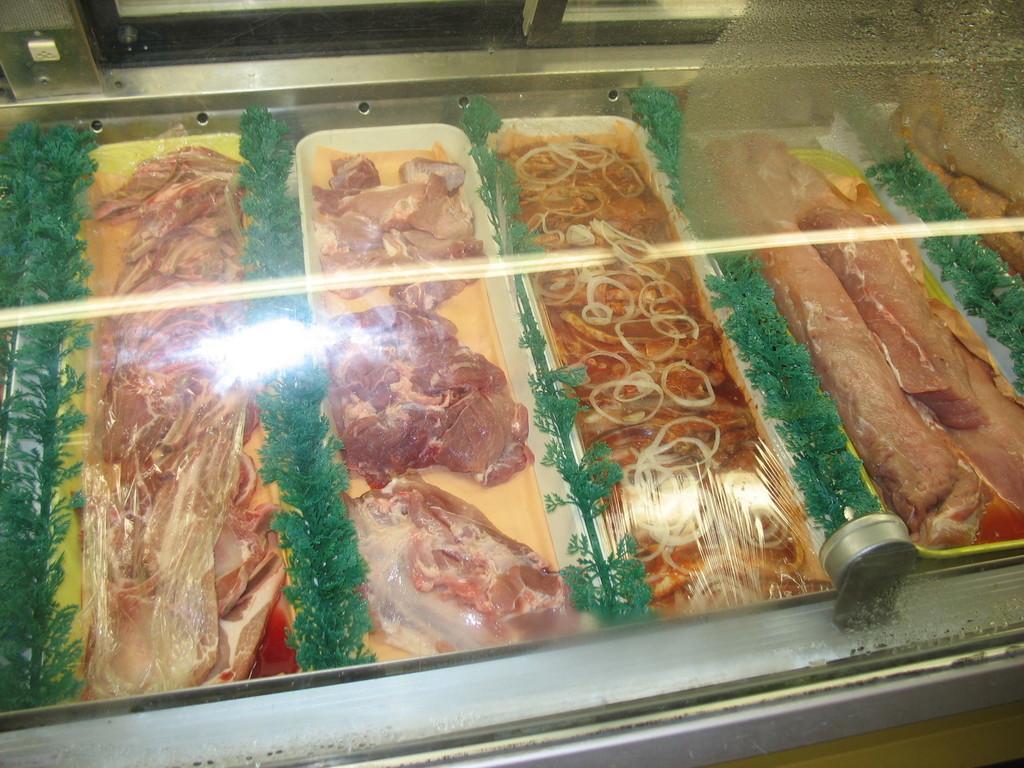Please provide a concise description of this image. In the picture we can see some trays of meat and with some plants garnish between the trays and they are placed under the glass. 